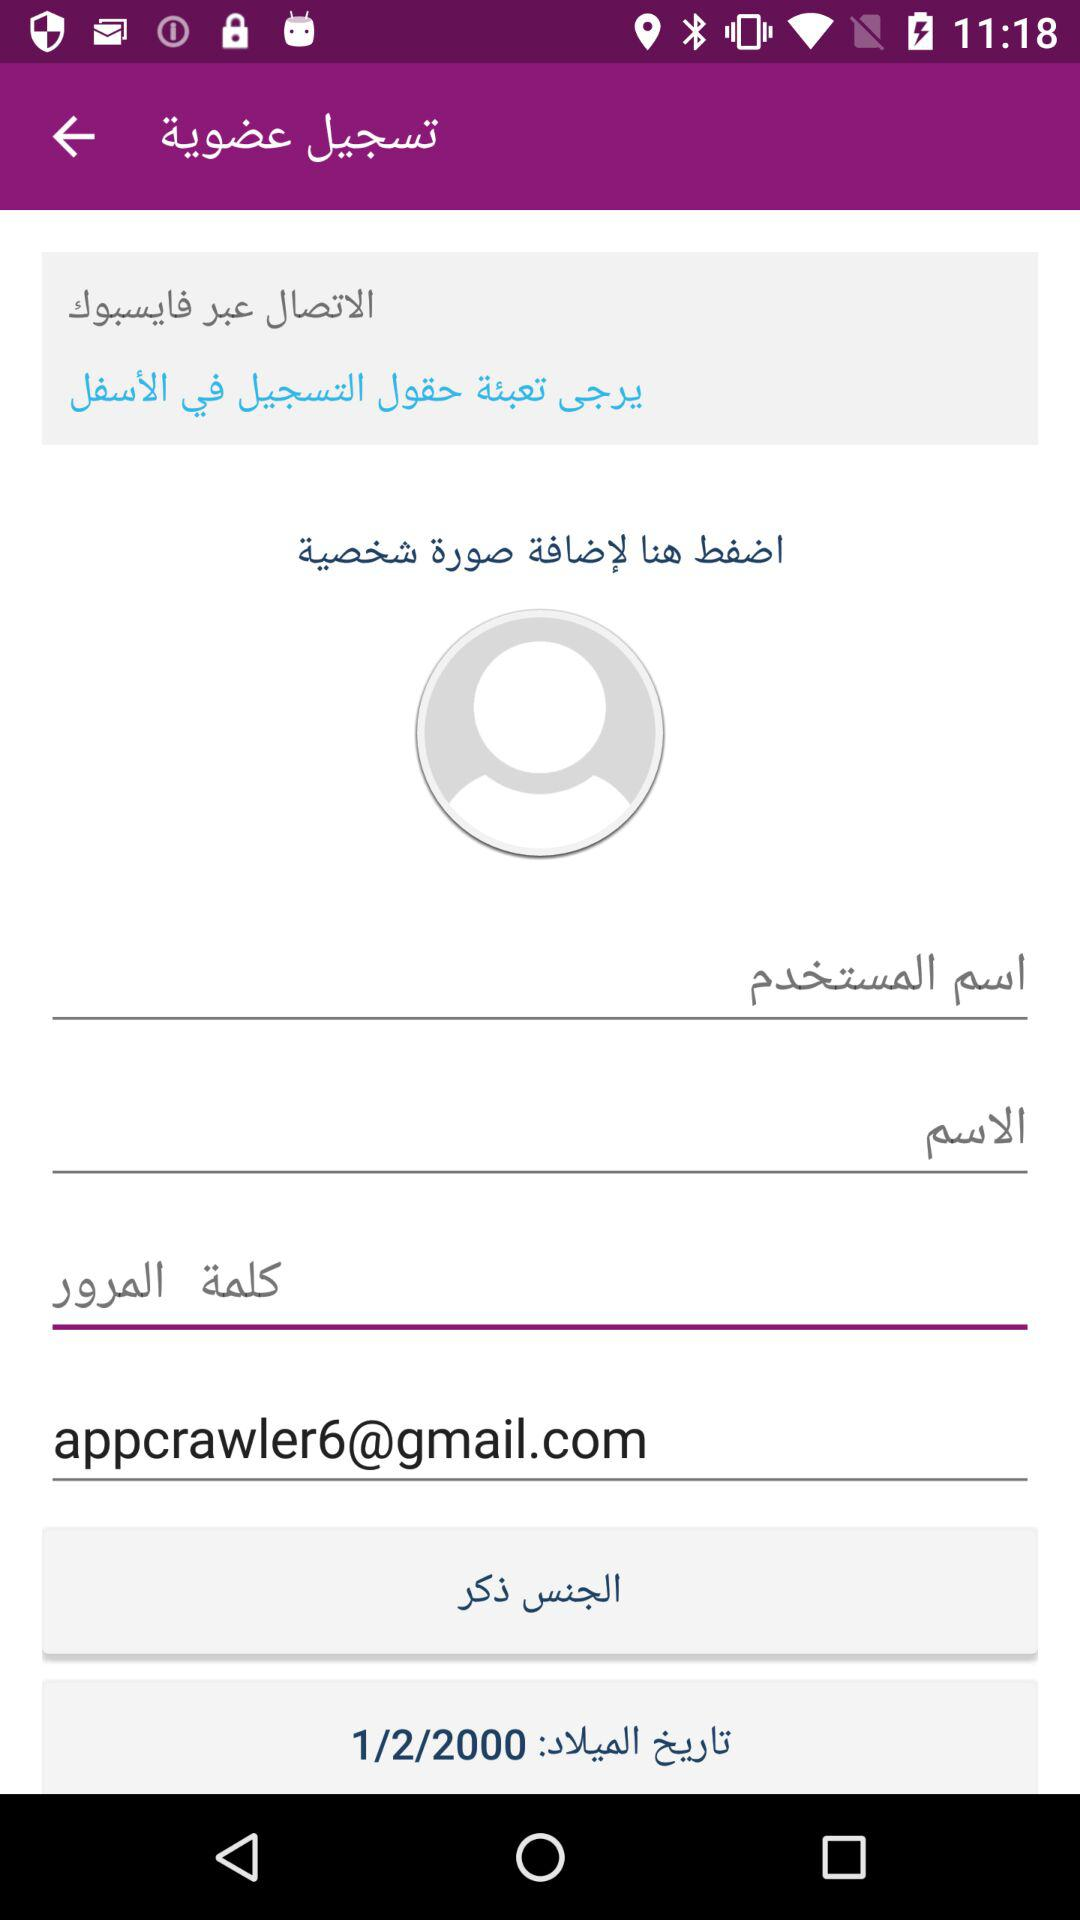How many text inputs are there for registering a new account?
Answer the question using a single word or phrase. 4 